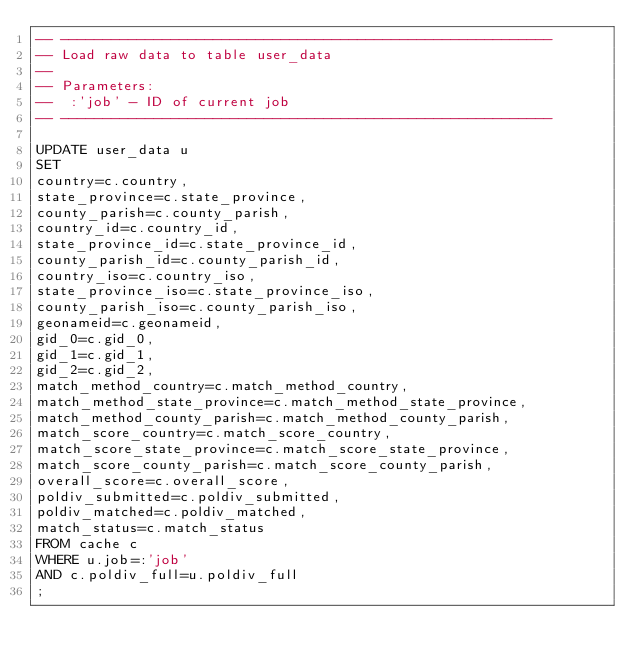Convert code to text. <code><loc_0><loc_0><loc_500><loc_500><_SQL_>-- ----------------------------------------------------------
-- Load raw data to table user_data
--
-- Parameters:
--	:'job' - ID of current job
-- ----------------------------------------------------------

UPDATE user_data u
SET
country=c.country,
state_province=c.state_province,
county_parish=c.county_parish,
country_id=c.country_id,
state_province_id=c.state_province_id,
county_parish_id=c.county_parish_id,
country_iso=c.country_iso,
state_province_iso=c.state_province_iso,
county_parish_iso=c.county_parish_iso,
geonameid=c.geonameid,
gid_0=c.gid_0,
gid_1=c.gid_1,
gid_2=c.gid_2,
match_method_country=c.match_method_country,
match_method_state_province=c.match_method_state_province,
match_method_county_parish=c.match_method_county_parish,
match_score_country=c.match_score_country,
match_score_state_province=c.match_score_state_province,
match_score_county_parish=c.match_score_county_parish,
overall_score=c.overall_score,
poldiv_submitted=c.poldiv_submitted,
poldiv_matched=c.poldiv_matched,
match_status=c.match_status
FROM cache c
WHERE u.job=:'job'
AND c.poldiv_full=u.poldiv_full
;</code> 